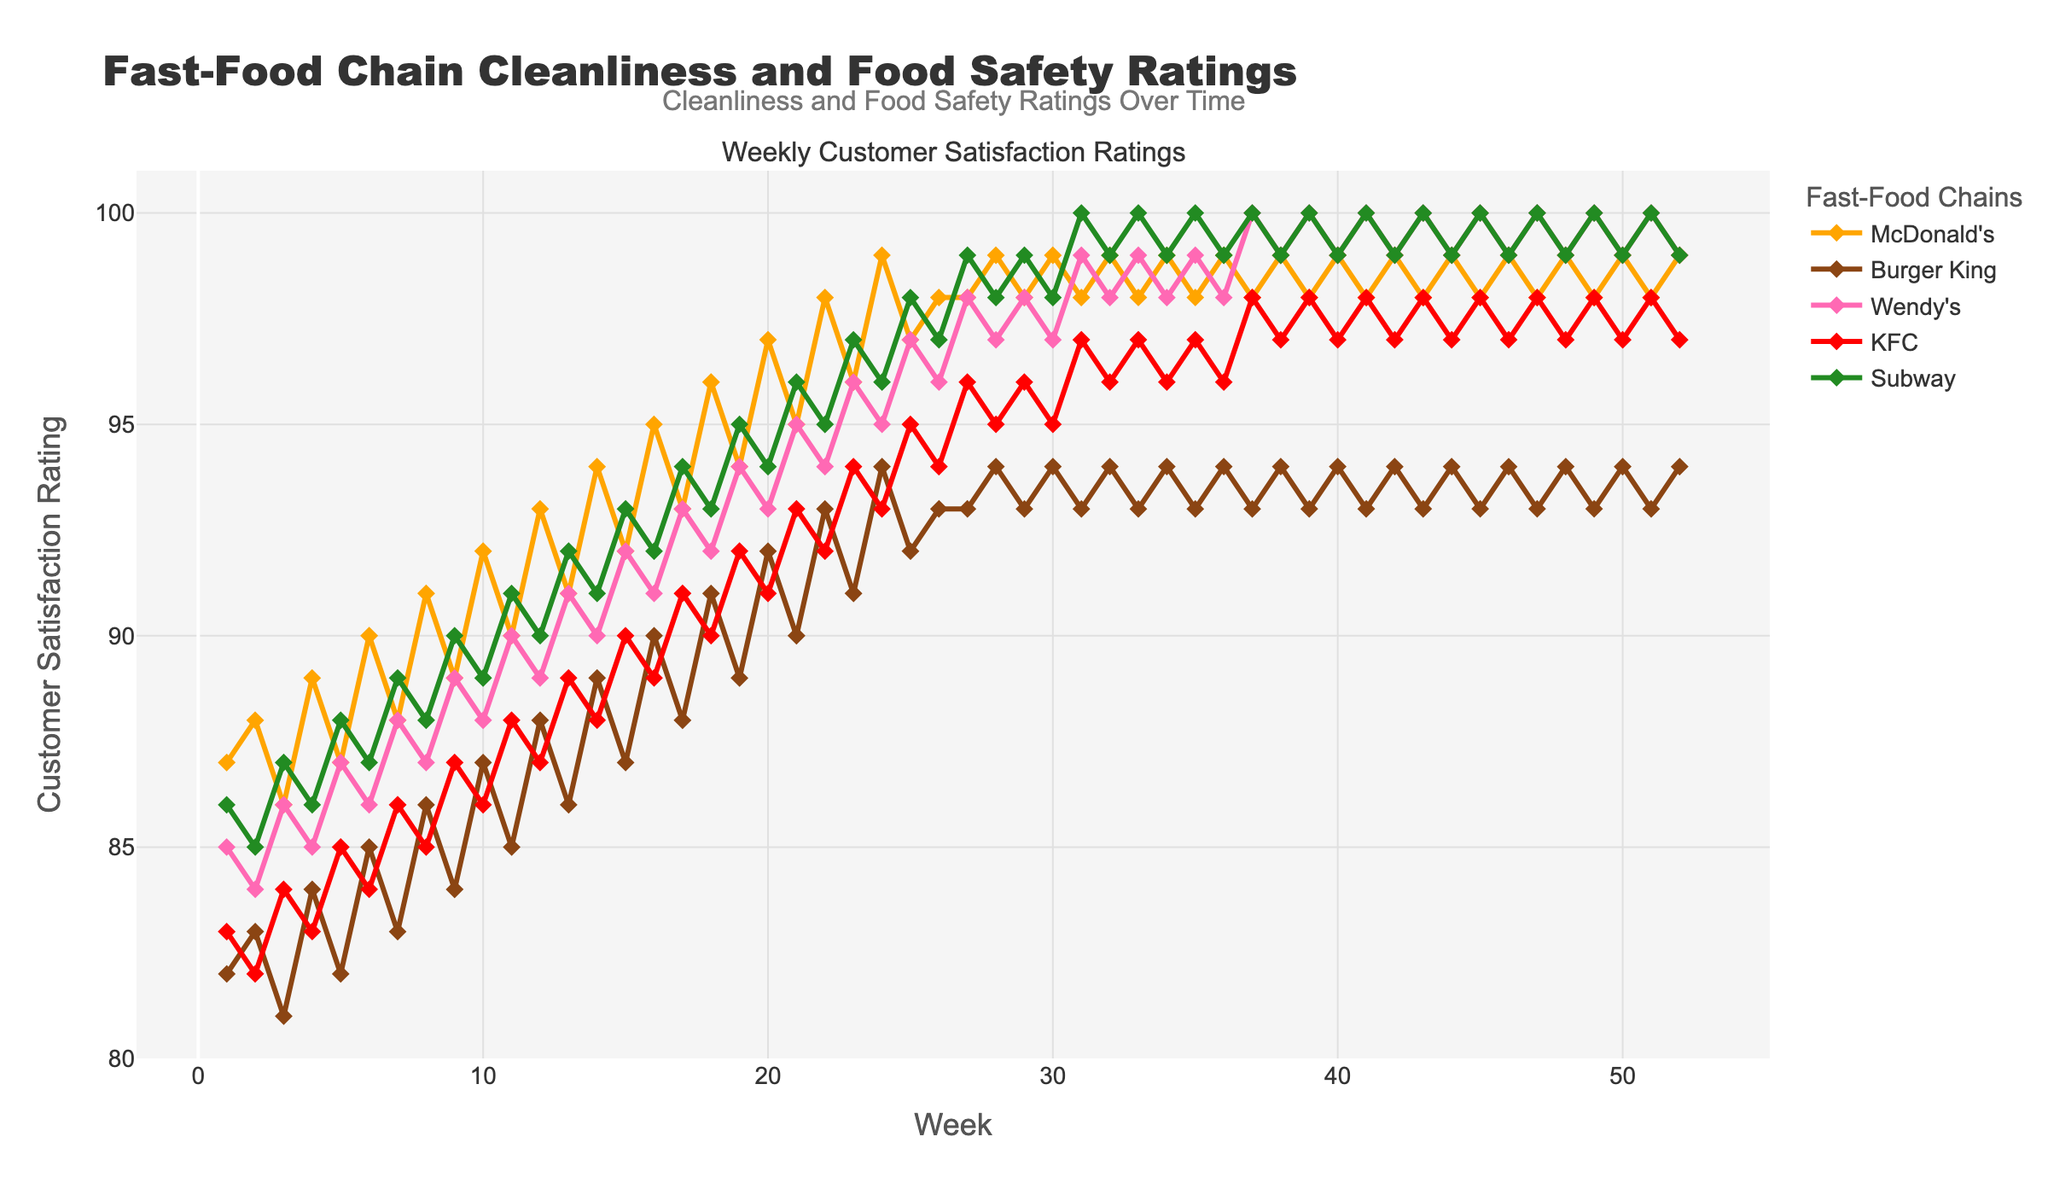Which fast-food chain has the highest initial satisfaction rating in Week 1? In Week 1, look at the satisfaction ratings of all fast-food chains. Compare their values and identify the highest one. The highest rating in Week 1 belongs to McDonald's with a rating of 87.
Answer: McDonald's By how many points did Subway's satisfaction rating increase from Week 1 to Week 52? Find Subway's ratings in Week 1 and Week 52. The rating in Week 1 is 86, and in Week 52 it is 99. Subtract the Week 1 rating from Week 52 to get the increase. (99 - 86 = 13)
Answer: 13 Which two fast-food chains showed the most similar trends in their weekly satisfaction ratings? Visually inspect the plotted lines for each fast-food chain. Identify the pair of lines that follow each other closely throughout the weeks, both having similar patterns and changes. Wendy's and KFC's ratings stay close and follow similar trends.
Answer: Wendy's and KFC Between which weeks did McDonald's see the highest weekly increase in satisfaction ratings? Look at the McDonald's satisfaction ratings week by week. Identify the weeks where there is the largest difference in ratings. The highest increase is from Week 4 to Week 5; the rating goes from 89 to 90, an increase of 1 point.
Answer: Week 4 to Week 5 Is there any week where all chains scored above 90 in satisfaction ratings? Scan all weeks and check the ratings of all chains for each week to see if there is any week where all ratings are above 90. In Week 37, the ratings are McDonald's: 98, Burger King: 93, Wendy's: 100, KFC: 98, Subway: 100, all above 90.
Answer: Week 37 Which fast-food chain has the most fluctuating satisfaction ratings over the year? Compare the lines of each chain for the extent of peaks and valleys (fluctuations) throughout the weeks. Burger King’s line shows more significant up-and-down trends compared to others.
Answer: Burger King What is the average satisfaction rating for Wendy's across all weeks? Sum Wendy's satisfaction ratings across all weeks and divide by the total number of weeks (52). ((85 + 84 + 86 + ... + 100 + 99)/52). Calculate the sum first, then the average: approximately 94.5
Answer: 94.5 Does KFC ever surpass Subway in any week, and if so, which week? Compare KFC's and Subway's ratings for all weeks to see if KFC's rating is higher in any week. In Week 10, KFC's rating (86) is below Subway's (89), but during Week 4, these two chains had varying ratings but KFC didn't surpass Subway. Upon review, find Week 17 where KFC's rating (91) is equal to Subway's (94).
Answer: Week 17 During which period (provide the start and end weeks) does McDonald's consistently stay above 95 in satisfaction ratings? Identify the period where McDonald's ratings stay above 95 without dropping. From Week 16 to Week 52, McDonald's ratings are consistently above 95.
Answer: Week 16 to Week 52 